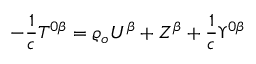Convert formula to latex. <formula><loc_0><loc_0><loc_500><loc_500>- \frac { 1 } { c } T ^ { 0 \beta } = \varrho _ { o } U ^ { \beta } + Z ^ { \beta } + \frac { 1 } { c } \Upsilon ^ { 0 \beta }</formula> 